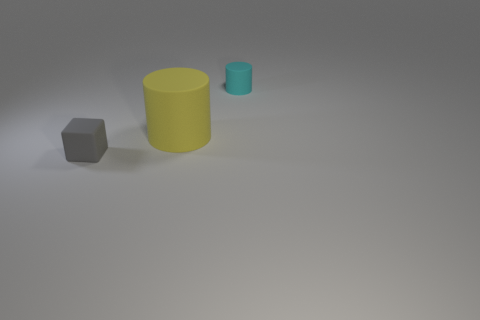Add 3 tiny cyan matte things. How many objects exist? 6 Subtract all cylinders. How many objects are left? 1 Add 3 yellow objects. How many yellow objects exist? 4 Subtract 0 cyan spheres. How many objects are left? 3 Subtract all cyan objects. Subtract all tiny cyan cylinders. How many objects are left? 1 Add 3 yellow cylinders. How many yellow cylinders are left? 4 